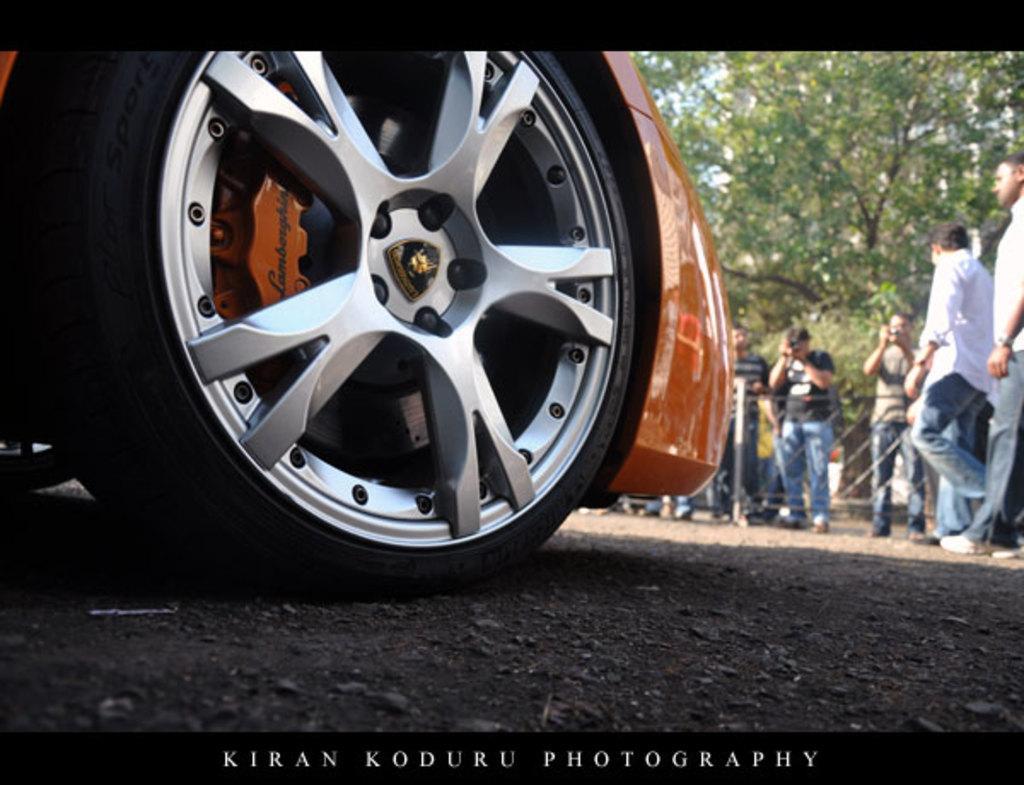Could you give a brief overview of what you see in this image? In this picture, we can see partially covered vehicle, and a few people, among them a few are taking photos, and we can see the ground, fencing, trees, and some text in the bottom side of the picture. 